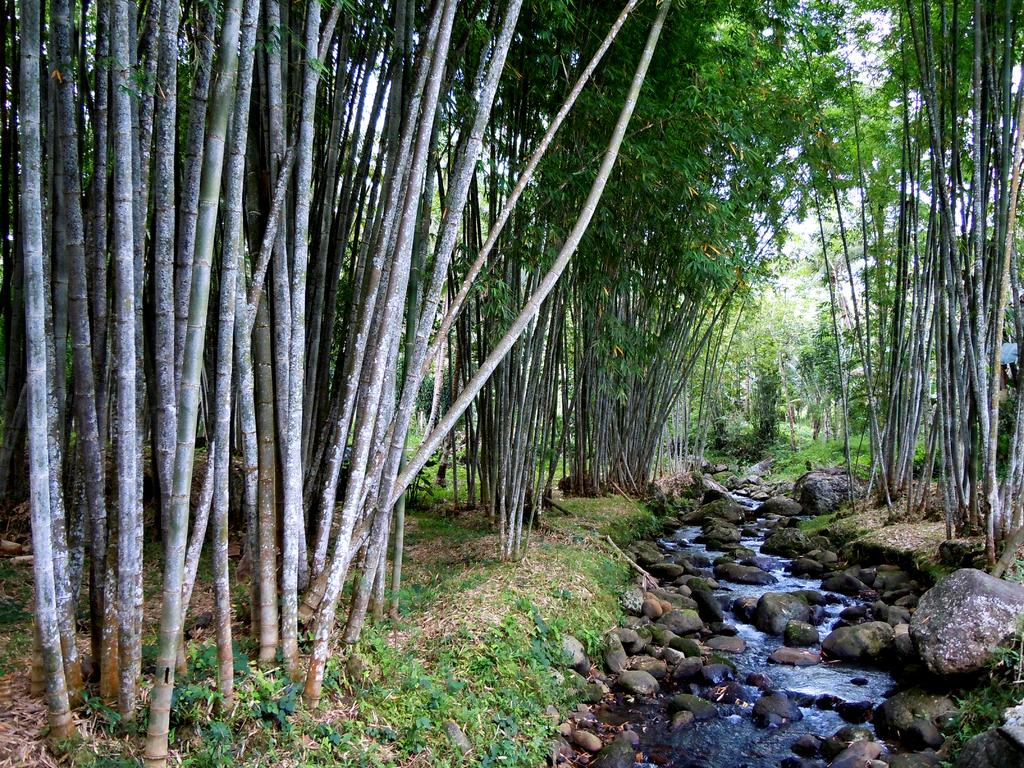What is the primary element present in the image? There is water in the image. What other objects can be seen in the image? There are rocks in the image. What can be seen in the background of the image? Trees and the sky are visible in the background of the image. What type of lamp is hanging from the tree in the image? There is no lamp present in the image, nor is there a tree mentioned in the facts. 